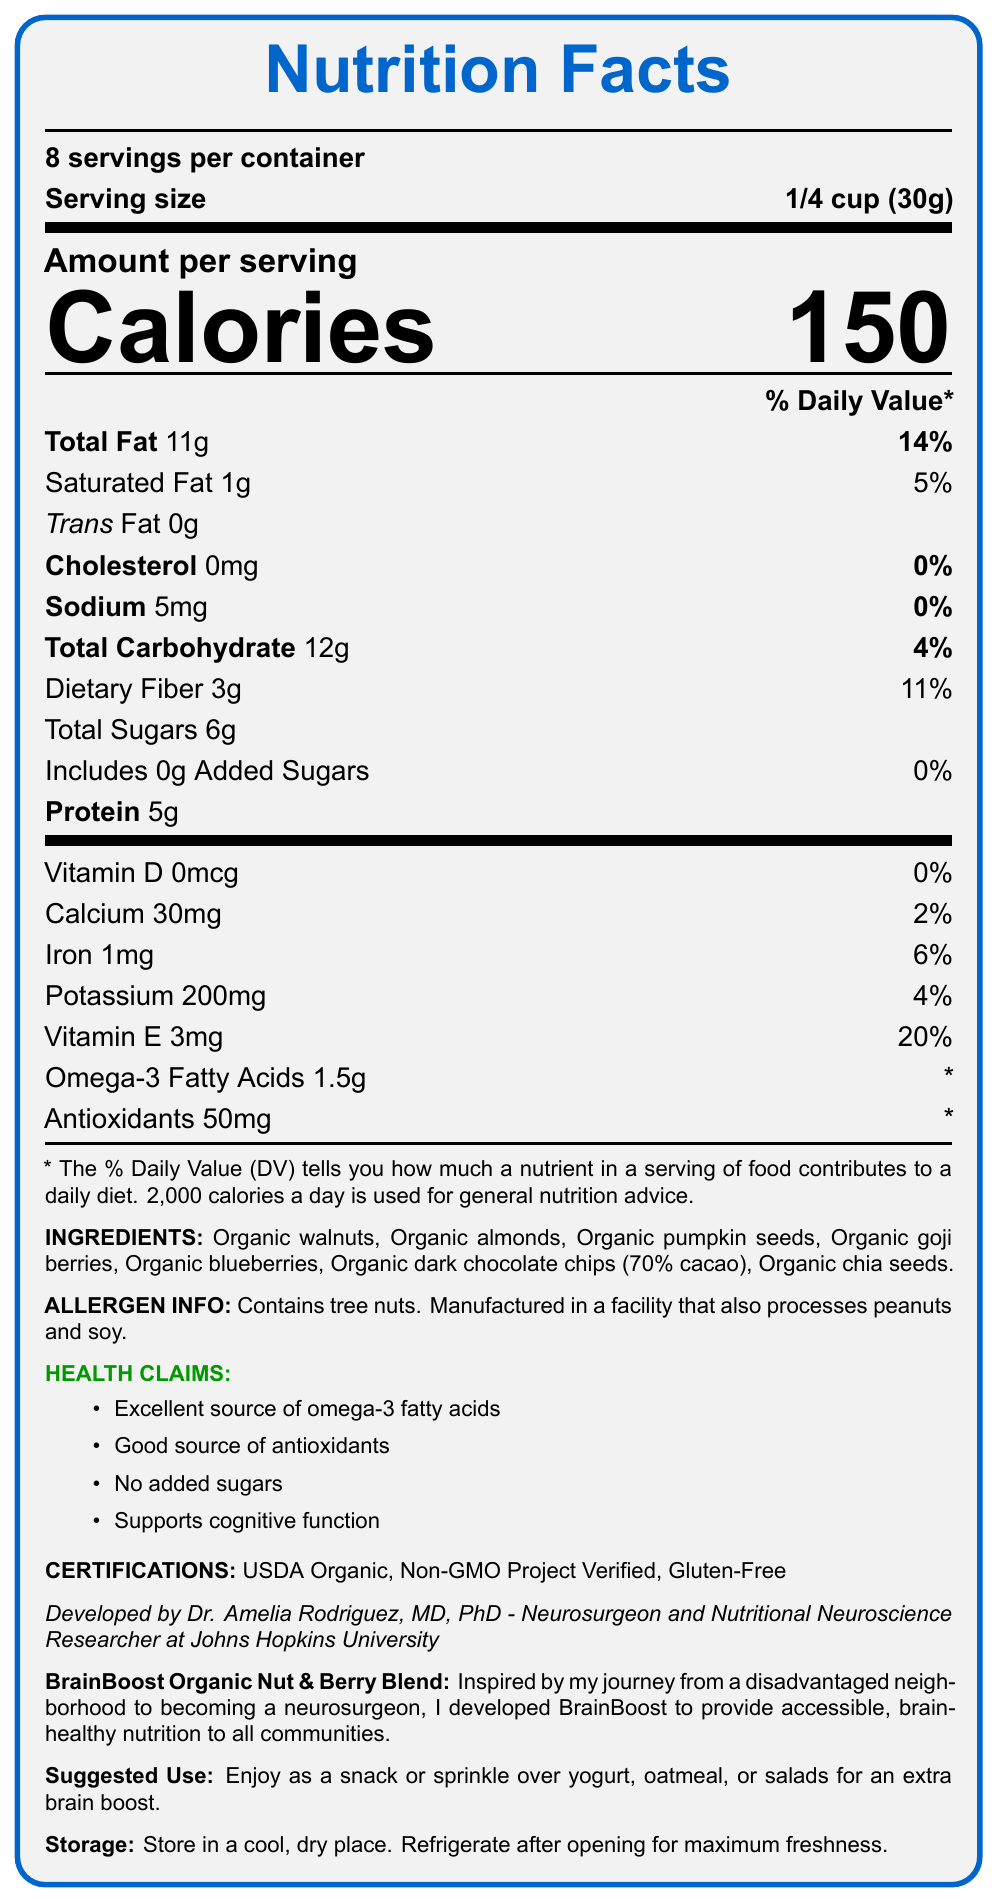what is the product name? The product name is mentioned at the beginning of the document.
Answer: BrainBoost Organic Nut & Berry Blend what is the serving size? The serving size is listed as "1/4 cup (30g)".
Answer: 1/4 cup (30g) how many calories are there per serving? The amount of calories per serving is noted as 150.
Answer: 150 what is the daily value percentage of total fat per serving? The daily value percentage for total fat per serving is given as 14%.
Answer: 14% what are the main ingredients of the product? The ingredients are listed under the "INGREDIENTS" section.
Answer: Organic walnuts, Organic almonds, Organic pumpkin seeds, Organic goji berries, Organic blueberries, Organic dark chocolate chips (70% cacao), Organic chia seeds how much protein does one serving contain? The protein content per serving is listed as 5 grams.
Answer: 5g what is the daily value percentage of dietary fiber per serving? The daily value percentage of dietary fiber is mentioned as 11%.
Answer: 11% which certification(s) does this product hold? The certifications are listed as USDA Organic, Non-GMO Project Verified, and Gluten-Free.
Answer: USDA Organic, Non-GMO Project Verified, Gluten-Free who developed this product? A. Dr. Amelia Rodriguez B. Dr. John Smith C. Dr. Emily Clark According to the document, Dr. Amelia Rodriguez, MD, PhD, developed the product.
Answer: A what is the daily value percentage of calcium per serving? A. 6% B. 4% C. 2% The daily value percentage of calcium per serving is given as 2%.
Answer: C does the product contain added sugars? The document explicitly states that the product includes 0g of added sugars (0% DV).
Answer: No is the product developed to support cognitive function? One of the health claims listed is "Supports cognitive function".
Answer: Yes what certifications are highlighted for the product? The document lists these three certifications under the "CERTIFICATIONS" section.
Answer: USDA Organic, Non-GMO Project Verified, Gluten-Free summarize the main contents of the document. The document provides comprehensive information on the product, including serving size, nutrition facts, ingredients, health claims, certifications, developer, and usage instructions.
Answer: The document serves as a Nutrition Facts Label for BrainBoost Organic Nut & Berry Blend. It includes nutritional information, ingredients, allergen information, health claims, certifications, and product story. The snack is designed for optimal brain health and developed by a neurosurgeon. what facility processes this product? The document states that the product is manufactured in a facility that also processes peanuts and soy but does not provide the name or location of the facility.
Answer: Cannot be determined 